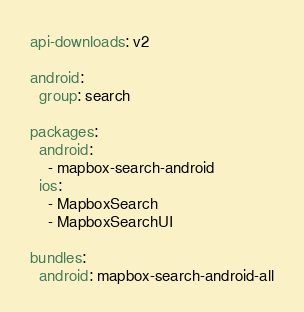Convert code to text. <code><loc_0><loc_0><loc_500><loc_500><_YAML_>api-downloads: v2

android:
  group: search

packages:
  android:
    - mapbox-search-android
  ios:
    - MapboxSearch
    - MapboxSearchUI

bundles:
  android: mapbox-search-android-all
</code> 